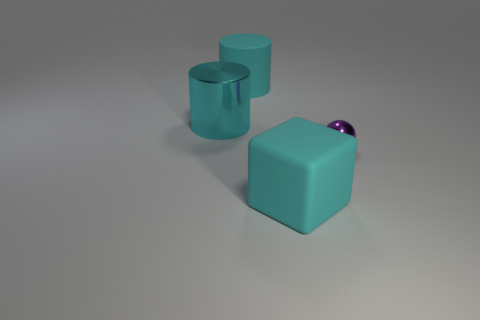Subtract all green blocks. Subtract all purple cylinders. How many blocks are left? 1 Add 2 tiny gray balls. How many objects exist? 6 Subtract all cubes. How many objects are left? 3 Subtract all big cyan rubber objects. Subtract all big red rubber things. How many objects are left? 2 Add 1 small purple objects. How many small purple objects are left? 2 Add 2 shiny spheres. How many shiny spheres exist? 3 Subtract 0 red balls. How many objects are left? 4 